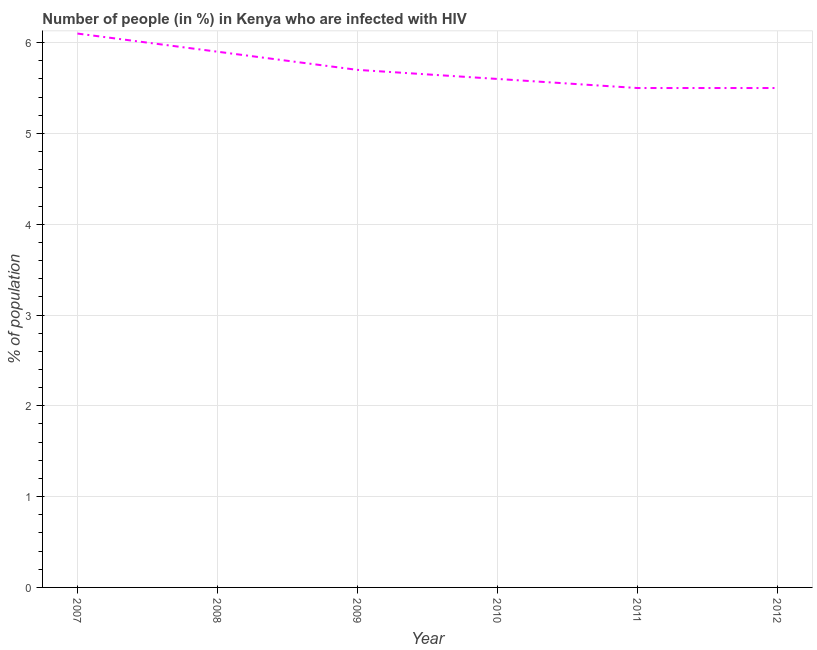What is the number of people infected with hiv in 2009?
Ensure brevity in your answer.  5.7. Across all years, what is the maximum number of people infected with hiv?
Give a very brief answer. 6.1. Across all years, what is the minimum number of people infected with hiv?
Offer a terse response. 5.5. In which year was the number of people infected with hiv maximum?
Provide a succinct answer. 2007. What is the sum of the number of people infected with hiv?
Offer a terse response. 34.3. What is the difference between the number of people infected with hiv in 2008 and 2009?
Offer a very short reply. 0.2. What is the average number of people infected with hiv per year?
Keep it short and to the point. 5.72. What is the median number of people infected with hiv?
Your answer should be very brief. 5.65. In how many years, is the number of people infected with hiv greater than 2.8 %?
Your response must be concise. 6. Do a majority of the years between 2011 and 2008 (inclusive) have number of people infected with hiv greater than 4.2 %?
Offer a terse response. Yes. What is the ratio of the number of people infected with hiv in 2007 to that in 2012?
Provide a succinct answer. 1.11. Is the number of people infected with hiv in 2007 less than that in 2008?
Give a very brief answer. No. What is the difference between the highest and the second highest number of people infected with hiv?
Your response must be concise. 0.2. Is the sum of the number of people infected with hiv in 2011 and 2012 greater than the maximum number of people infected with hiv across all years?
Provide a succinct answer. Yes. What is the difference between the highest and the lowest number of people infected with hiv?
Your answer should be very brief. 0.6. Does the graph contain any zero values?
Provide a short and direct response. No. What is the title of the graph?
Provide a succinct answer. Number of people (in %) in Kenya who are infected with HIV. What is the label or title of the X-axis?
Give a very brief answer. Year. What is the label or title of the Y-axis?
Your answer should be compact. % of population. What is the % of population in 2008?
Offer a very short reply. 5.9. What is the % of population of 2010?
Make the answer very short. 5.6. What is the % of population of 2011?
Your answer should be very brief. 5.5. What is the difference between the % of population in 2007 and 2009?
Your answer should be compact. 0.4. What is the difference between the % of population in 2007 and 2012?
Provide a succinct answer. 0.6. What is the difference between the % of population in 2008 and 2010?
Your response must be concise. 0.3. What is the difference between the % of population in 2008 and 2011?
Offer a very short reply. 0.4. What is the difference between the % of population in 2008 and 2012?
Your response must be concise. 0.4. What is the difference between the % of population in 2009 and 2011?
Keep it short and to the point. 0.2. What is the ratio of the % of population in 2007 to that in 2008?
Ensure brevity in your answer.  1.03. What is the ratio of the % of population in 2007 to that in 2009?
Offer a terse response. 1.07. What is the ratio of the % of population in 2007 to that in 2010?
Provide a succinct answer. 1.09. What is the ratio of the % of population in 2007 to that in 2011?
Keep it short and to the point. 1.11. What is the ratio of the % of population in 2007 to that in 2012?
Keep it short and to the point. 1.11. What is the ratio of the % of population in 2008 to that in 2009?
Your response must be concise. 1.03. What is the ratio of the % of population in 2008 to that in 2010?
Provide a succinct answer. 1.05. What is the ratio of the % of population in 2008 to that in 2011?
Your answer should be compact. 1.07. What is the ratio of the % of population in 2008 to that in 2012?
Make the answer very short. 1.07. What is the ratio of the % of population in 2009 to that in 2010?
Ensure brevity in your answer.  1.02. What is the ratio of the % of population in 2009 to that in 2011?
Offer a very short reply. 1.04. What is the ratio of the % of population in 2009 to that in 2012?
Make the answer very short. 1.04. What is the ratio of the % of population in 2010 to that in 2011?
Your answer should be very brief. 1.02. What is the ratio of the % of population in 2010 to that in 2012?
Your answer should be compact. 1.02. 